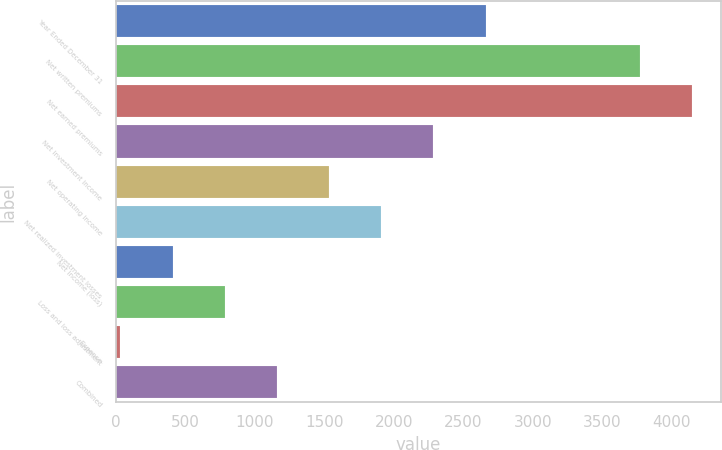Convert chart. <chart><loc_0><loc_0><loc_500><loc_500><bar_chart><fcel>Year Ended December 31<fcel>Net written premiums<fcel>Net earned premiums<fcel>Net investment income<fcel>Net operating income<fcel>Net realized investment losses<fcel>Net income (loss)<fcel>Loss and loss adjustment<fcel>Expense<fcel>Combined<nl><fcel>2660.26<fcel>3770<fcel>4145.58<fcel>2284.68<fcel>1533.52<fcel>1909.1<fcel>406.78<fcel>782.36<fcel>31.2<fcel>1157.94<nl></chart> 